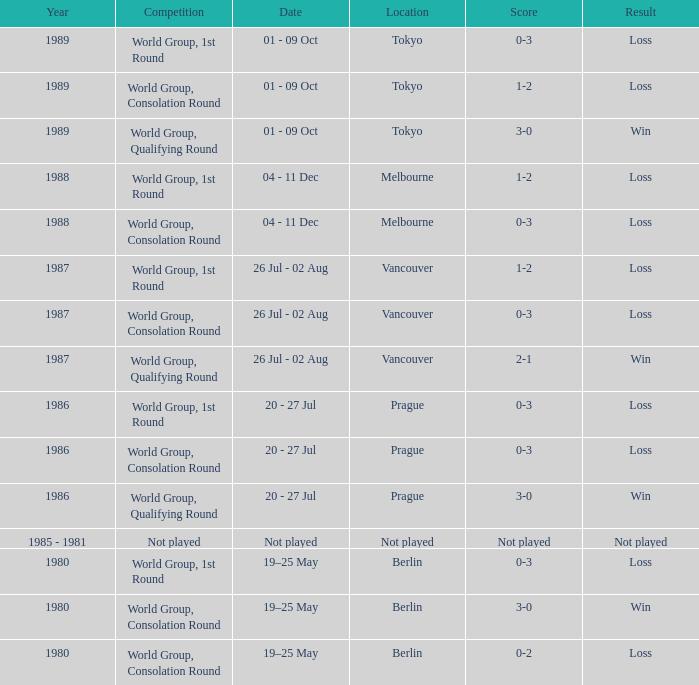What is the schedule for the match in prague for the world group, consolation round tournament? 20 - 27 Jul. 